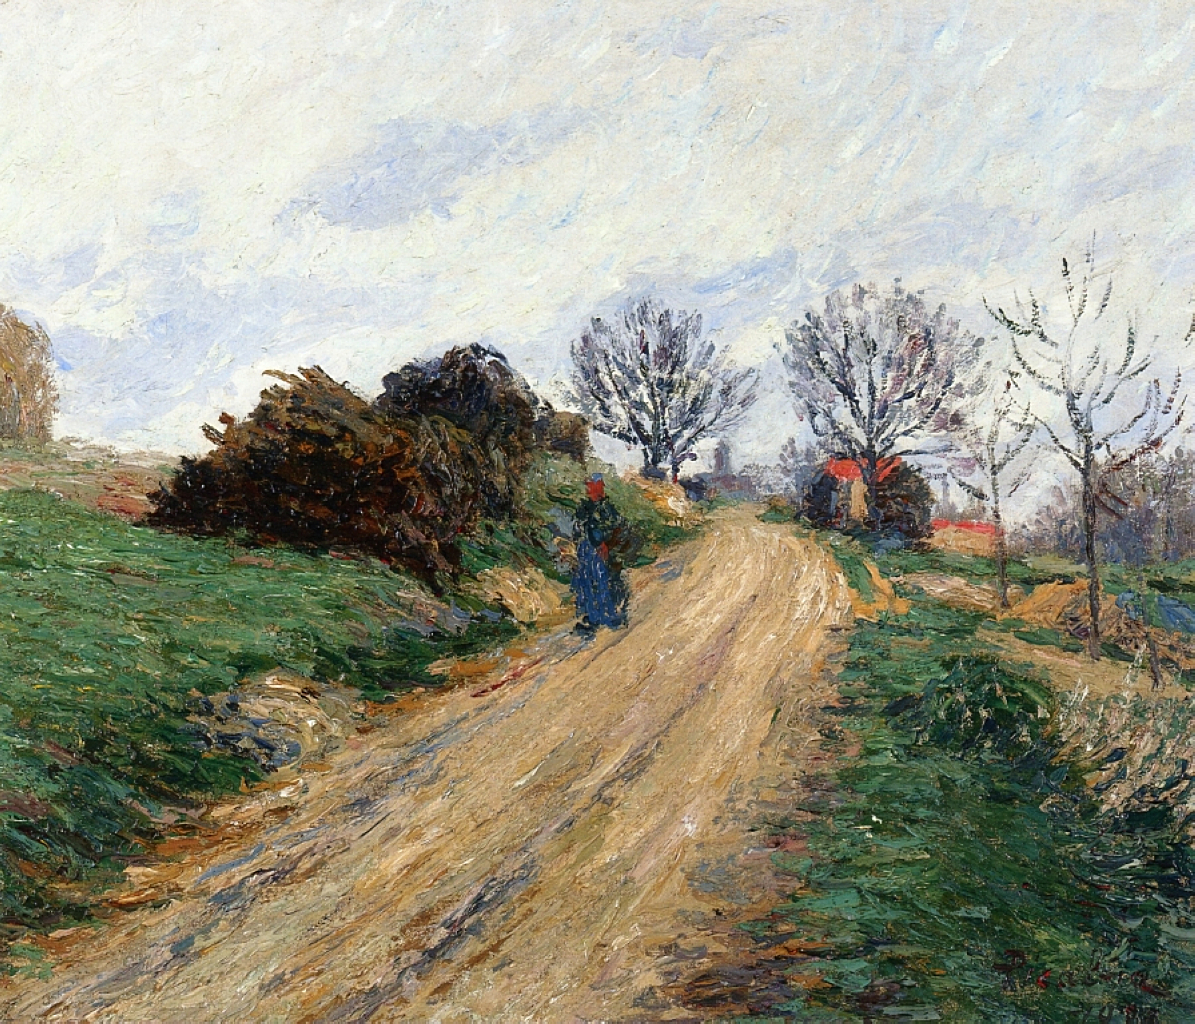Can you describe the emotional atmosphere of the painting? The emotional atmosphere of the painting is one of tranquility and nostalgia. The muted tones and soft lighting evoke a serene, peaceful feeling, as if capturing a quiet moment in the countryside. The emptiness of the road and sparse details of human presence suggest solitude, perhaps inviting viewers to reflect on the calmness and simplicity of rural life. The scene is evocative of a sense of timelessness, capturing the beauty of a fleeting moment in nature. 